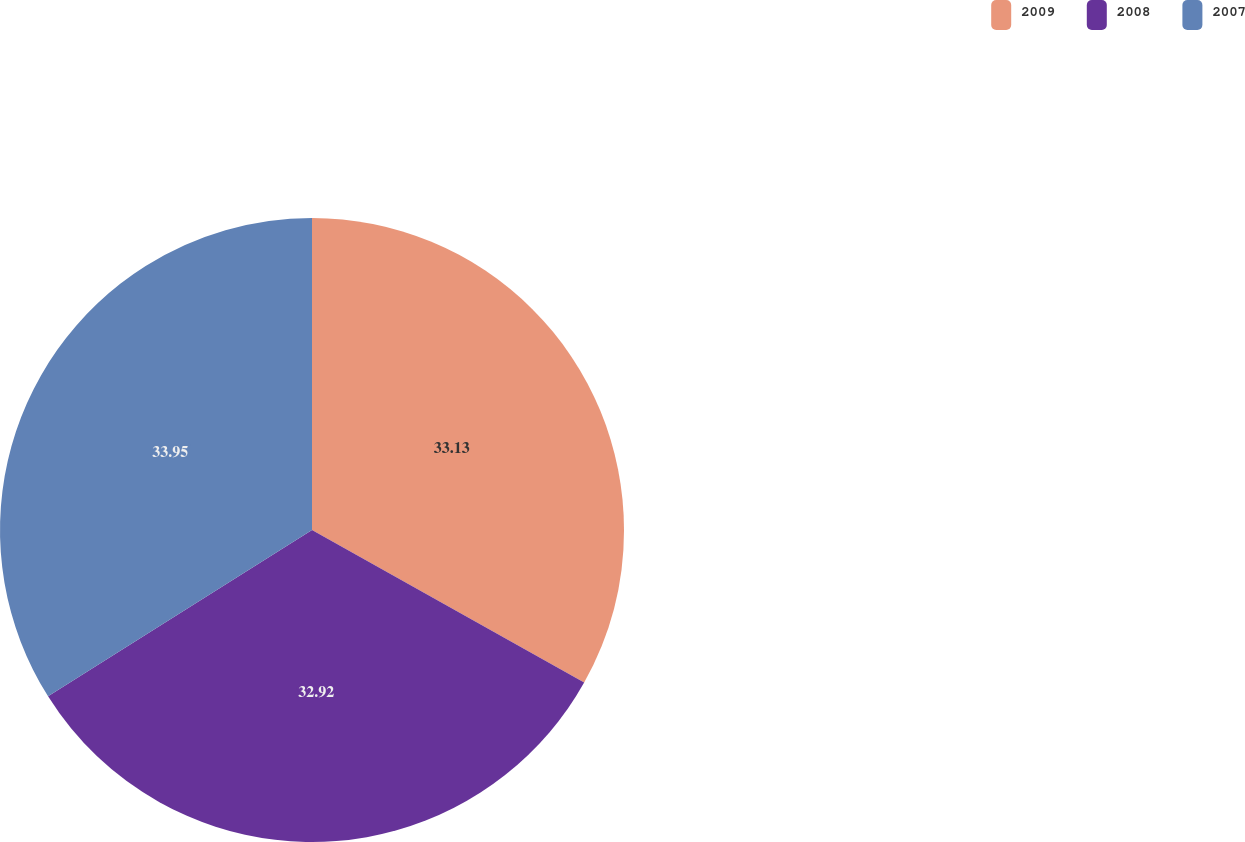<chart> <loc_0><loc_0><loc_500><loc_500><pie_chart><fcel>2009<fcel>2008<fcel>2007<nl><fcel>33.13%<fcel>32.92%<fcel>33.95%<nl></chart> 